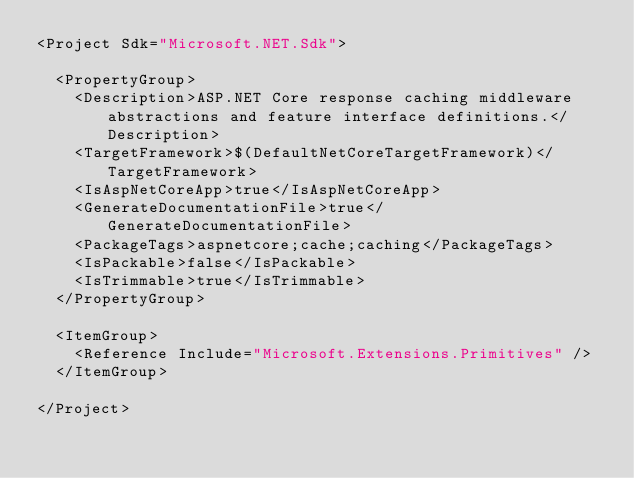Convert code to text. <code><loc_0><loc_0><loc_500><loc_500><_XML_><Project Sdk="Microsoft.NET.Sdk">

  <PropertyGroup>
    <Description>ASP.NET Core response caching middleware abstractions and feature interface definitions.</Description>
    <TargetFramework>$(DefaultNetCoreTargetFramework)</TargetFramework>
    <IsAspNetCoreApp>true</IsAspNetCoreApp>
    <GenerateDocumentationFile>true</GenerateDocumentationFile>
    <PackageTags>aspnetcore;cache;caching</PackageTags>
    <IsPackable>false</IsPackable>
    <IsTrimmable>true</IsTrimmable>
  </PropertyGroup>

  <ItemGroup>
    <Reference Include="Microsoft.Extensions.Primitives" />
  </ItemGroup>

</Project>
</code> 